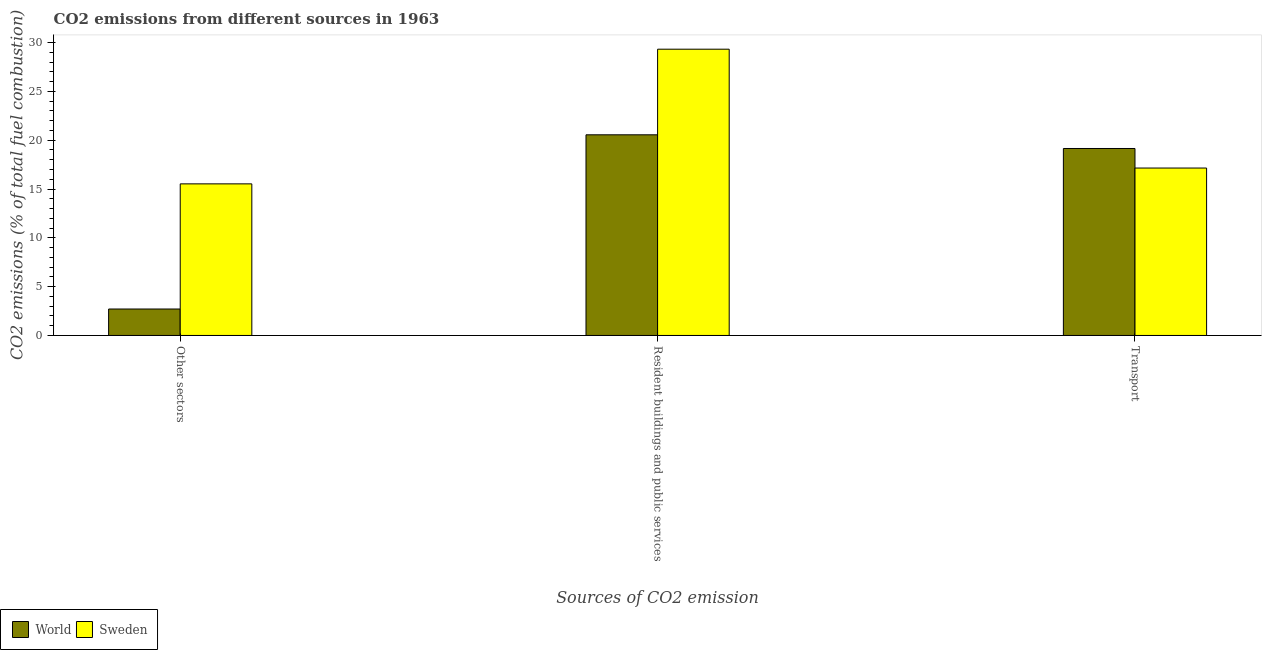How many different coloured bars are there?
Provide a succinct answer. 2. How many groups of bars are there?
Offer a very short reply. 3. How many bars are there on the 1st tick from the left?
Ensure brevity in your answer.  2. What is the label of the 3rd group of bars from the left?
Provide a short and direct response. Transport. What is the percentage of co2 emissions from transport in Sweden?
Give a very brief answer. 17.15. Across all countries, what is the maximum percentage of co2 emissions from other sectors?
Give a very brief answer. 15.53. Across all countries, what is the minimum percentage of co2 emissions from other sectors?
Your answer should be very brief. 2.71. In which country was the percentage of co2 emissions from resident buildings and public services minimum?
Your response must be concise. World. What is the total percentage of co2 emissions from other sectors in the graph?
Your response must be concise. 18.24. What is the difference between the percentage of co2 emissions from other sectors in Sweden and that in World?
Keep it short and to the point. 12.82. What is the difference between the percentage of co2 emissions from resident buildings and public services in Sweden and the percentage of co2 emissions from transport in World?
Give a very brief answer. 10.17. What is the average percentage of co2 emissions from transport per country?
Offer a terse response. 18.15. What is the difference between the percentage of co2 emissions from transport and percentage of co2 emissions from other sectors in World?
Your answer should be compact. 16.44. In how many countries, is the percentage of co2 emissions from other sectors greater than 13 %?
Your answer should be very brief. 1. What is the ratio of the percentage of co2 emissions from resident buildings and public services in Sweden to that in World?
Your response must be concise. 1.43. Is the percentage of co2 emissions from other sectors in World less than that in Sweden?
Ensure brevity in your answer.  Yes. Is the difference between the percentage of co2 emissions from resident buildings and public services in World and Sweden greater than the difference between the percentage of co2 emissions from other sectors in World and Sweden?
Your answer should be very brief. Yes. What is the difference between the highest and the second highest percentage of co2 emissions from transport?
Offer a terse response. 2. What is the difference between the highest and the lowest percentage of co2 emissions from resident buildings and public services?
Keep it short and to the point. 8.77. Is the sum of the percentage of co2 emissions from resident buildings and public services in Sweden and World greater than the maximum percentage of co2 emissions from transport across all countries?
Ensure brevity in your answer.  Yes. What does the 2nd bar from the left in Resident buildings and public services represents?
Keep it short and to the point. Sweden. Are all the bars in the graph horizontal?
Make the answer very short. No. What is the difference between two consecutive major ticks on the Y-axis?
Offer a very short reply. 5. Does the graph contain any zero values?
Offer a terse response. No. Does the graph contain grids?
Your answer should be very brief. No. How many legend labels are there?
Offer a terse response. 2. What is the title of the graph?
Make the answer very short. CO2 emissions from different sources in 1963. Does "Vanuatu" appear as one of the legend labels in the graph?
Your response must be concise. No. What is the label or title of the X-axis?
Your response must be concise. Sources of CO2 emission. What is the label or title of the Y-axis?
Make the answer very short. CO2 emissions (% of total fuel combustion). What is the CO2 emissions (% of total fuel combustion) in World in Other sectors?
Give a very brief answer. 2.71. What is the CO2 emissions (% of total fuel combustion) of Sweden in Other sectors?
Your response must be concise. 15.53. What is the CO2 emissions (% of total fuel combustion) of World in Resident buildings and public services?
Make the answer very short. 20.55. What is the CO2 emissions (% of total fuel combustion) in Sweden in Resident buildings and public services?
Keep it short and to the point. 29.32. What is the CO2 emissions (% of total fuel combustion) of World in Transport?
Make the answer very short. 19.15. What is the CO2 emissions (% of total fuel combustion) in Sweden in Transport?
Your response must be concise. 17.15. Across all Sources of CO2 emission, what is the maximum CO2 emissions (% of total fuel combustion) of World?
Give a very brief answer. 20.55. Across all Sources of CO2 emission, what is the maximum CO2 emissions (% of total fuel combustion) of Sweden?
Your response must be concise. 29.32. Across all Sources of CO2 emission, what is the minimum CO2 emissions (% of total fuel combustion) in World?
Give a very brief answer. 2.71. Across all Sources of CO2 emission, what is the minimum CO2 emissions (% of total fuel combustion) of Sweden?
Provide a succinct answer. 15.53. What is the total CO2 emissions (% of total fuel combustion) in World in the graph?
Provide a succinct answer. 42.41. What is the total CO2 emissions (% of total fuel combustion) of Sweden in the graph?
Offer a very short reply. 61.99. What is the difference between the CO2 emissions (% of total fuel combustion) in World in Other sectors and that in Resident buildings and public services?
Provide a succinct answer. -17.84. What is the difference between the CO2 emissions (% of total fuel combustion) in Sweden in Other sectors and that in Resident buildings and public services?
Offer a very short reply. -13.79. What is the difference between the CO2 emissions (% of total fuel combustion) of World in Other sectors and that in Transport?
Provide a succinct answer. -16.44. What is the difference between the CO2 emissions (% of total fuel combustion) of Sweden in Other sectors and that in Transport?
Give a very brief answer. -1.62. What is the difference between the CO2 emissions (% of total fuel combustion) of World in Resident buildings and public services and that in Transport?
Keep it short and to the point. 1.4. What is the difference between the CO2 emissions (% of total fuel combustion) of Sweden in Resident buildings and public services and that in Transport?
Offer a terse response. 12.17. What is the difference between the CO2 emissions (% of total fuel combustion) of World in Other sectors and the CO2 emissions (% of total fuel combustion) of Sweden in Resident buildings and public services?
Give a very brief answer. -26.61. What is the difference between the CO2 emissions (% of total fuel combustion) of World in Other sectors and the CO2 emissions (% of total fuel combustion) of Sweden in Transport?
Your response must be concise. -14.44. What is the difference between the CO2 emissions (% of total fuel combustion) in World in Resident buildings and public services and the CO2 emissions (% of total fuel combustion) in Sweden in Transport?
Make the answer very short. 3.4. What is the average CO2 emissions (% of total fuel combustion) in World per Sources of CO2 emission?
Offer a very short reply. 14.14. What is the average CO2 emissions (% of total fuel combustion) in Sweden per Sources of CO2 emission?
Provide a succinct answer. 20.66. What is the difference between the CO2 emissions (% of total fuel combustion) in World and CO2 emissions (% of total fuel combustion) in Sweden in Other sectors?
Offer a very short reply. -12.82. What is the difference between the CO2 emissions (% of total fuel combustion) in World and CO2 emissions (% of total fuel combustion) in Sweden in Resident buildings and public services?
Provide a short and direct response. -8.77. What is the difference between the CO2 emissions (% of total fuel combustion) in World and CO2 emissions (% of total fuel combustion) in Sweden in Transport?
Keep it short and to the point. 2. What is the ratio of the CO2 emissions (% of total fuel combustion) in World in Other sectors to that in Resident buildings and public services?
Keep it short and to the point. 0.13. What is the ratio of the CO2 emissions (% of total fuel combustion) of Sweden in Other sectors to that in Resident buildings and public services?
Provide a short and direct response. 0.53. What is the ratio of the CO2 emissions (% of total fuel combustion) of World in Other sectors to that in Transport?
Your response must be concise. 0.14. What is the ratio of the CO2 emissions (% of total fuel combustion) of Sweden in Other sectors to that in Transport?
Ensure brevity in your answer.  0.91. What is the ratio of the CO2 emissions (% of total fuel combustion) of World in Resident buildings and public services to that in Transport?
Your answer should be compact. 1.07. What is the ratio of the CO2 emissions (% of total fuel combustion) of Sweden in Resident buildings and public services to that in Transport?
Your answer should be very brief. 1.71. What is the difference between the highest and the second highest CO2 emissions (% of total fuel combustion) of World?
Provide a succinct answer. 1.4. What is the difference between the highest and the second highest CO2 emissions (% of total fuel combustion) of Sweden?
Make the answer very short. 12.17. What is the difference between the highest and the lowest CO2 emissions (% of total fuel combustion) of World?
Ensure brevity in your answer.  17.84. What is the difference between the highest and the lowest CO2 emissions (% of total fuel combustion) of Sweden?
Offer a very short reply. 13.79. 